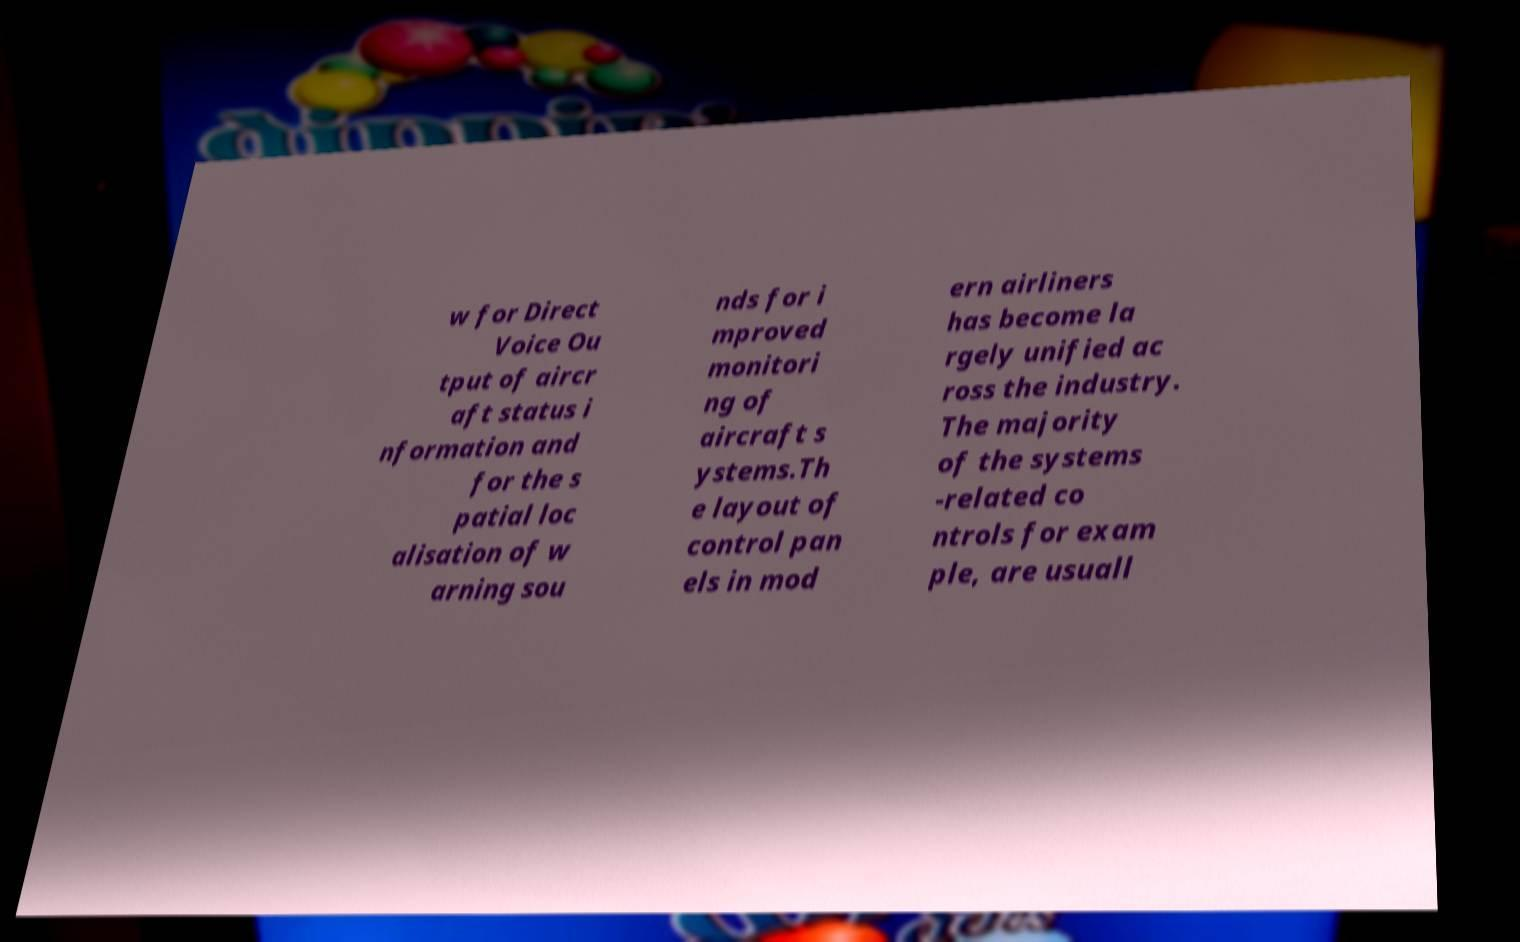Can you read and provide the text displayed in the image?This photo seems to have some interesting text. Can you extract and type it out for me? w for Direct Voice Ou tput of aircr aft status i nformation and for the s patial loc alisation of w arning sou nds for i mproved monitori ng of aircraft s ystems.Th e layout of control pan els in mod ern airliners has become la rgely unified ac ross the industry. The majority of the systems -related co ntrols for exam ple, are usuall 